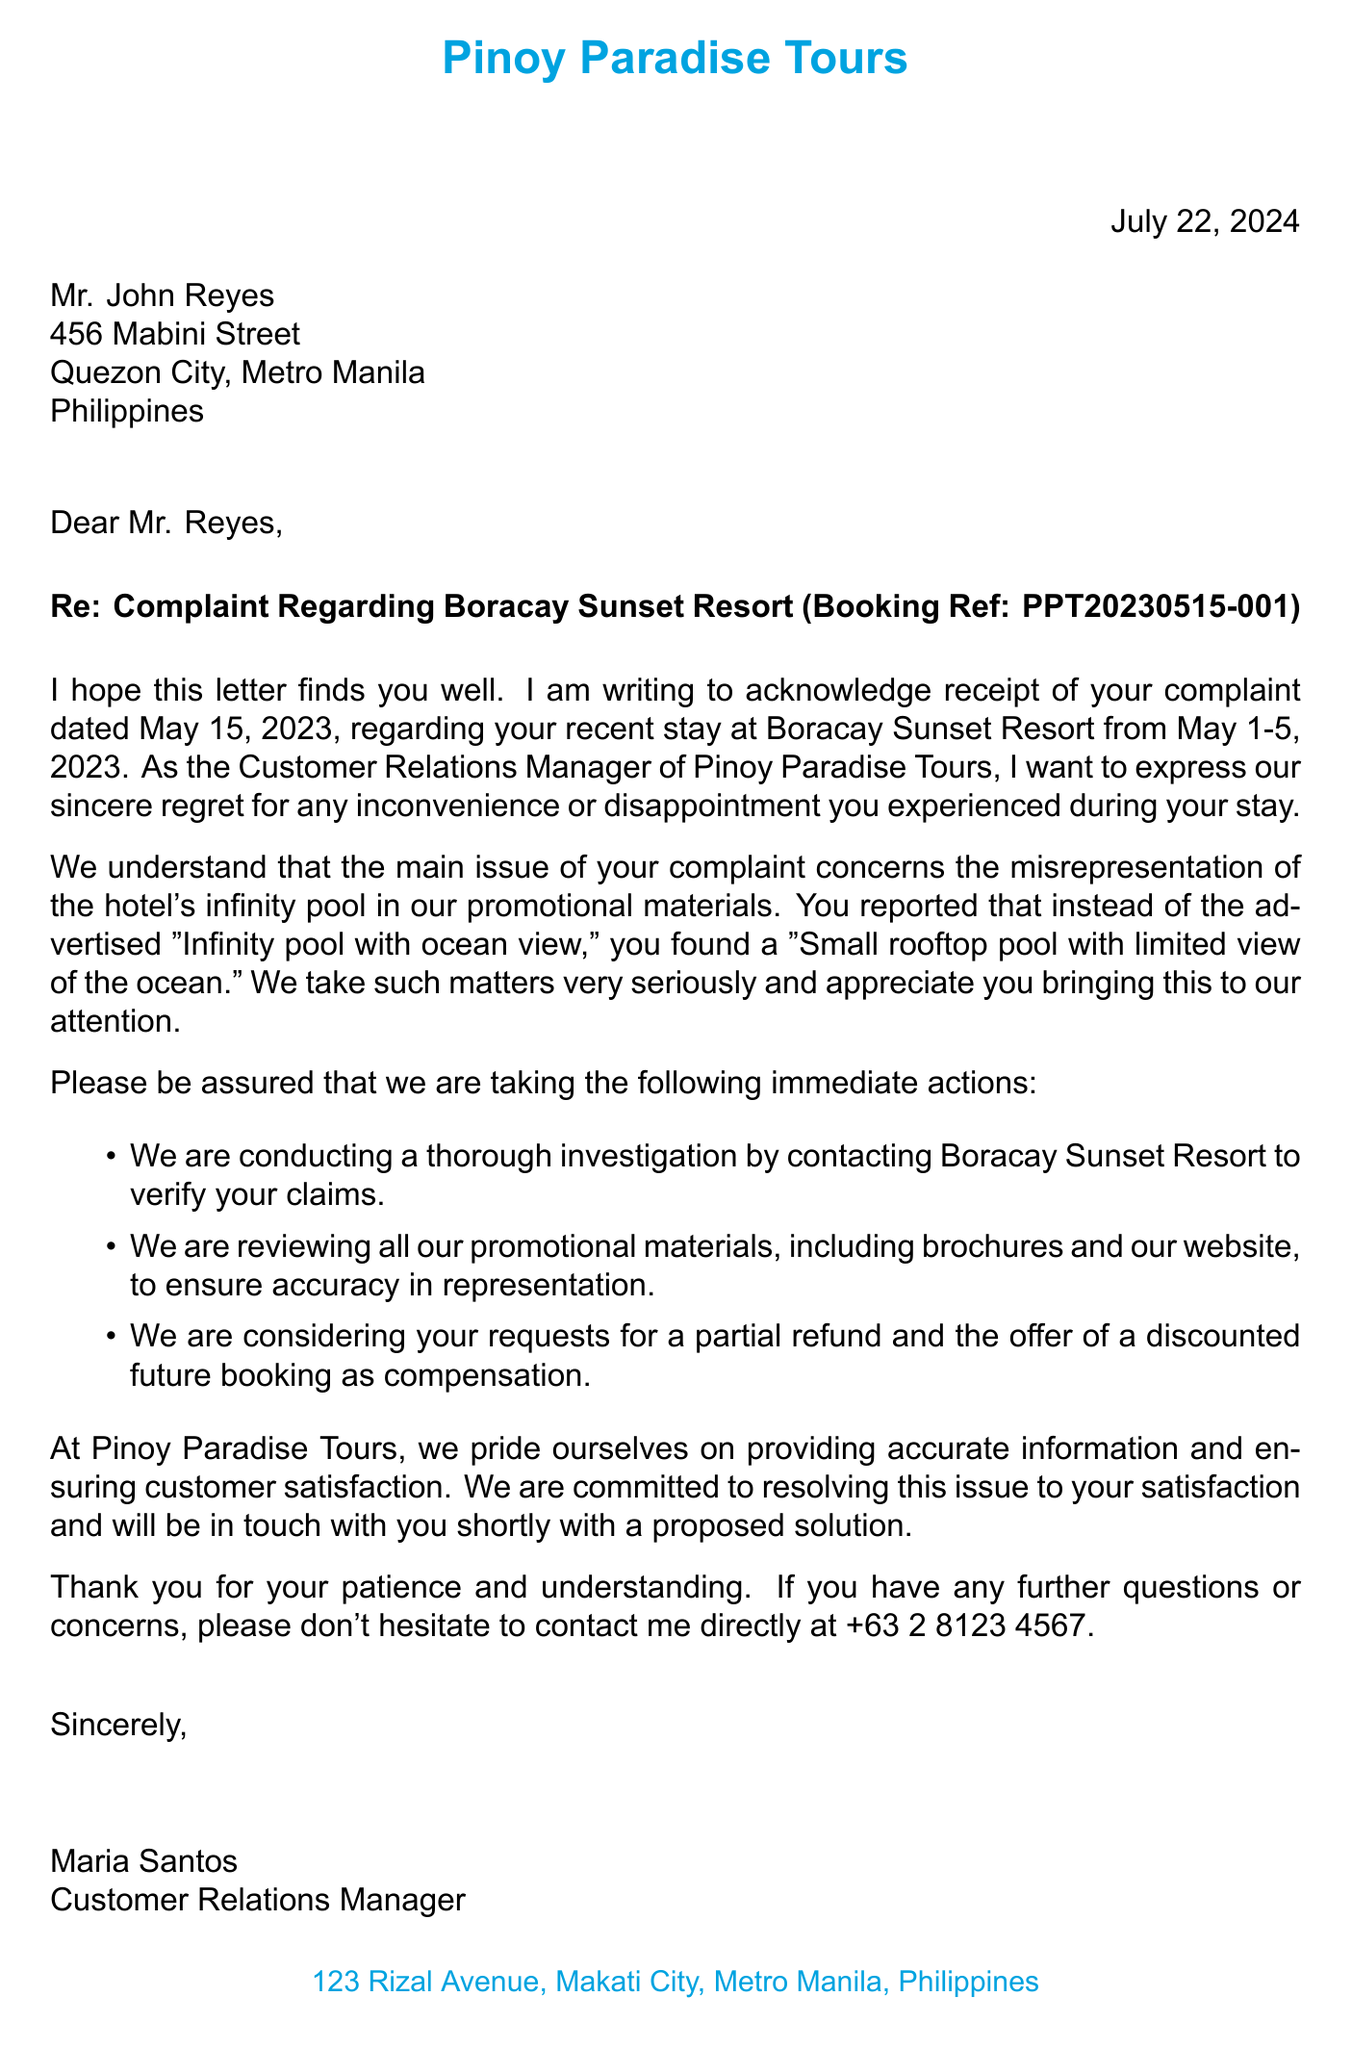What is the name of the travel agency? The travel agency's name is mentioned at the beginning of the document.
Answer: Pinoy Paradise Tours Who is the contact person at the agency? The letter states the contact person's name and position.
Answer: Maria Santos What is Mr. Reyes's booking reference number? The booking reference is specified in the subject line of the letter.
Answer: PPT20230515-001 What date did Mr. Reyes stay at the hotel? The stay duration is noted in the complaint details section of the letter.
Answer: May 1-5, 2023 What amenity was misrepresented in the promotional materials? The letter highlights the specific amenity that was incorrectly advertised.
Answer: Infinity pool with ocean view What was the actual situation of the pool? The document clearly states the actual condition of the pool that patients experienced.
Answer: Small rooftop pool with limited view of the ocean What action is being considered regarding the client's requests? The document lists the requested actions in relation to the complaint.
Answer: Partial refund What is the date the complaint was made? The letter mentions when the complaint was received.
Answer: May 15, 2023 What does the agency plan to do about their promotional materials? The intention regarding promotional materials is outlined in the immediate actions.
Answer: Review and update for accuracy 